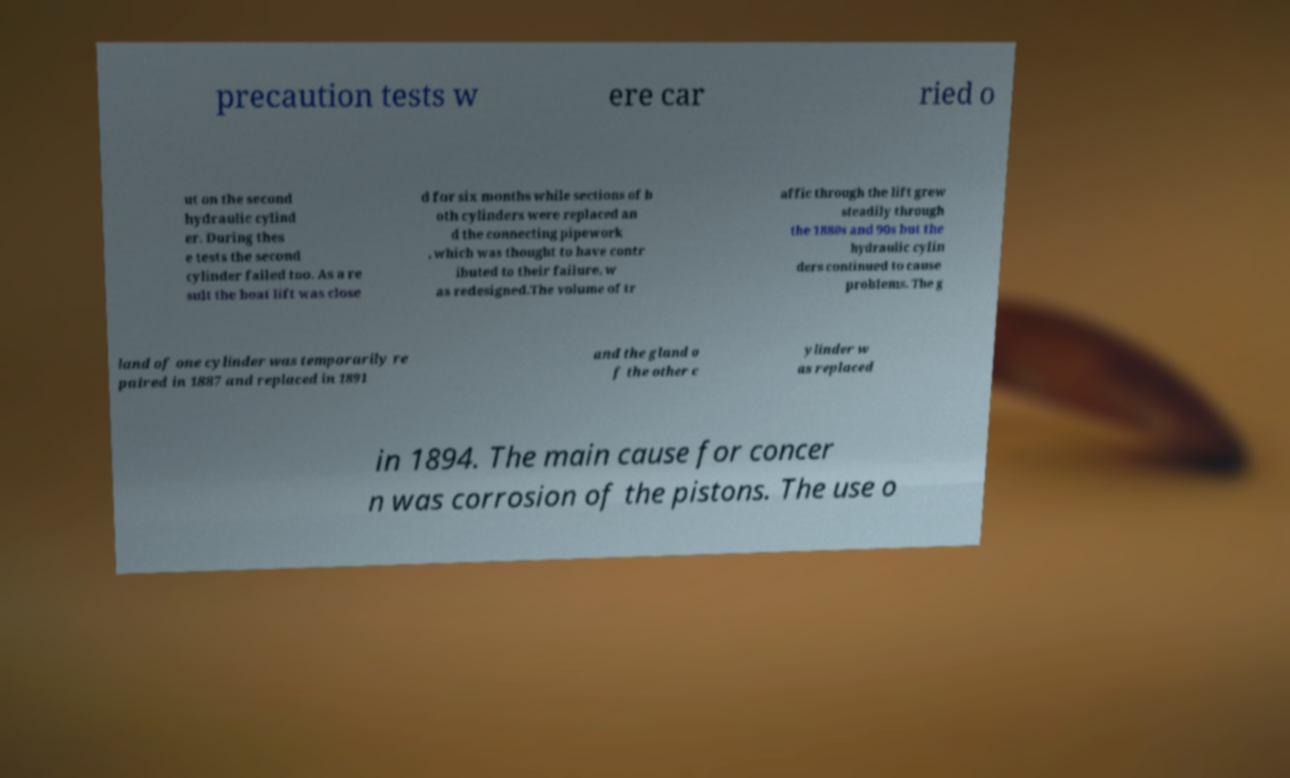Could you extract and type out the text from this image? precaution tests w ere car ried o ut on the second hydraulic cylind er. During thes e tests the second cylinder failed too. As a re sult the boat lift was close d for six months while sections of b oth cylinders were replaced an d the connecting pipework , which was thought to have contr ibuted to their failure, w as redesigned.The volume of tr affic through the lift grew steadily through the 1880s and 90s but the hydraulic cylin ders continued to cause problems. The g land of one cylinder was temporarily re paired in 1887 and replaced in 1891 and the gland o f the other c ylinder w as replaced in 1894. The main cause for concer n was corrosion of the pistons. The use o 